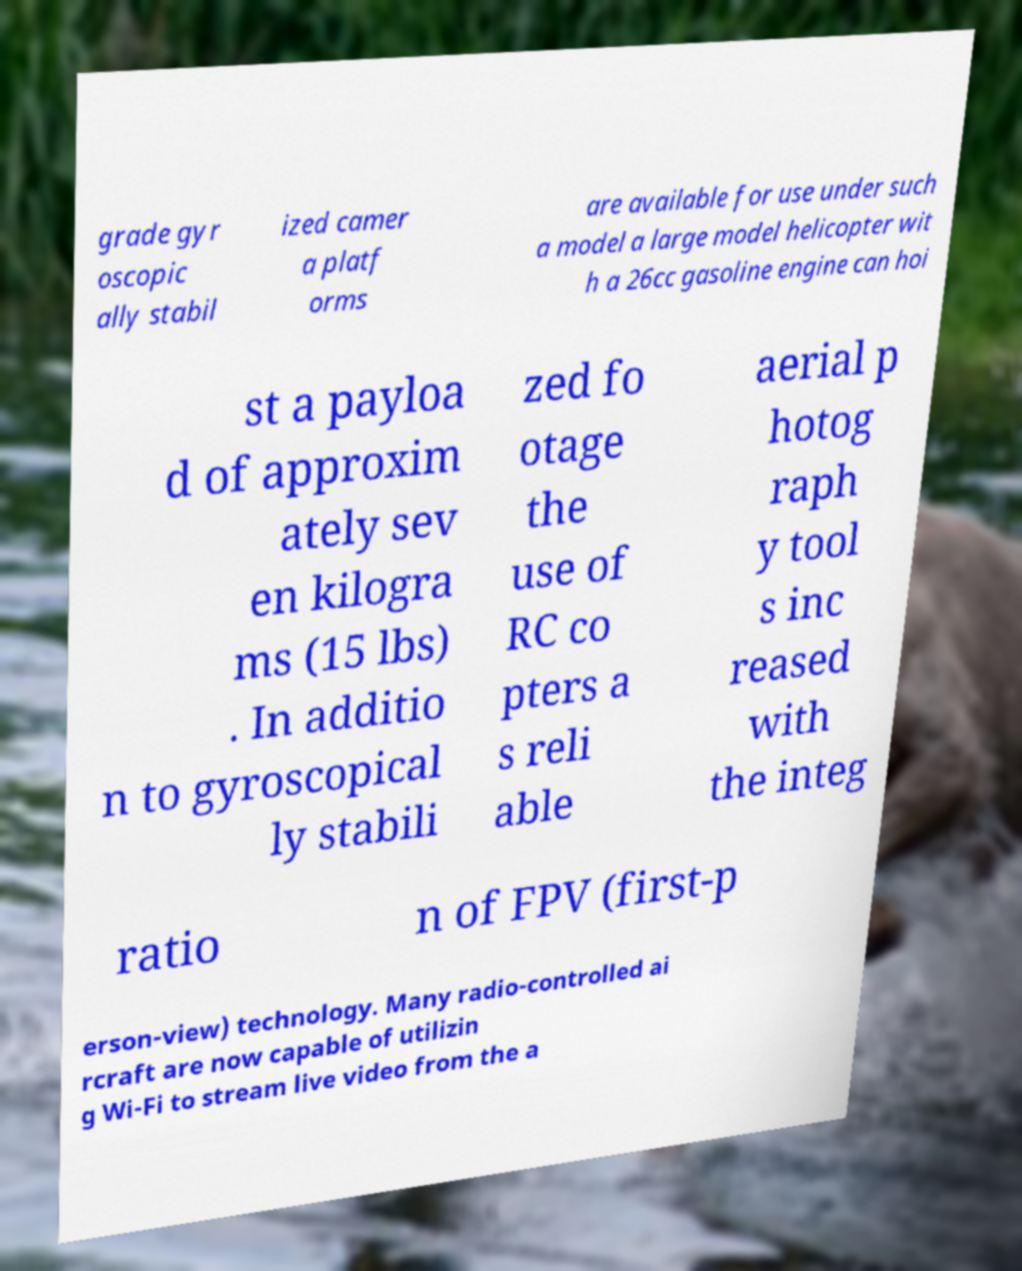I need the written content from this picture converted into text. Can you do that? grade gyr oscopic ally stabil ized camer a platf orms are available for use under such a model a large model helicopter wit h a 26cc gasoline engine can hoi st a payloa d of approxim ately sev en kilogra ms (15 lbs) . In additio n to gyroscopical ly stabili zed fo otage the use of RC co pters a s reli able aerial p hotog raph y tool s inc reased with the integ ratio n of FPV (first-p erson-view) technology. Many radio-controlled ai rcraft are now capable of utilizin g Wi-Fi to stream live video from the a 